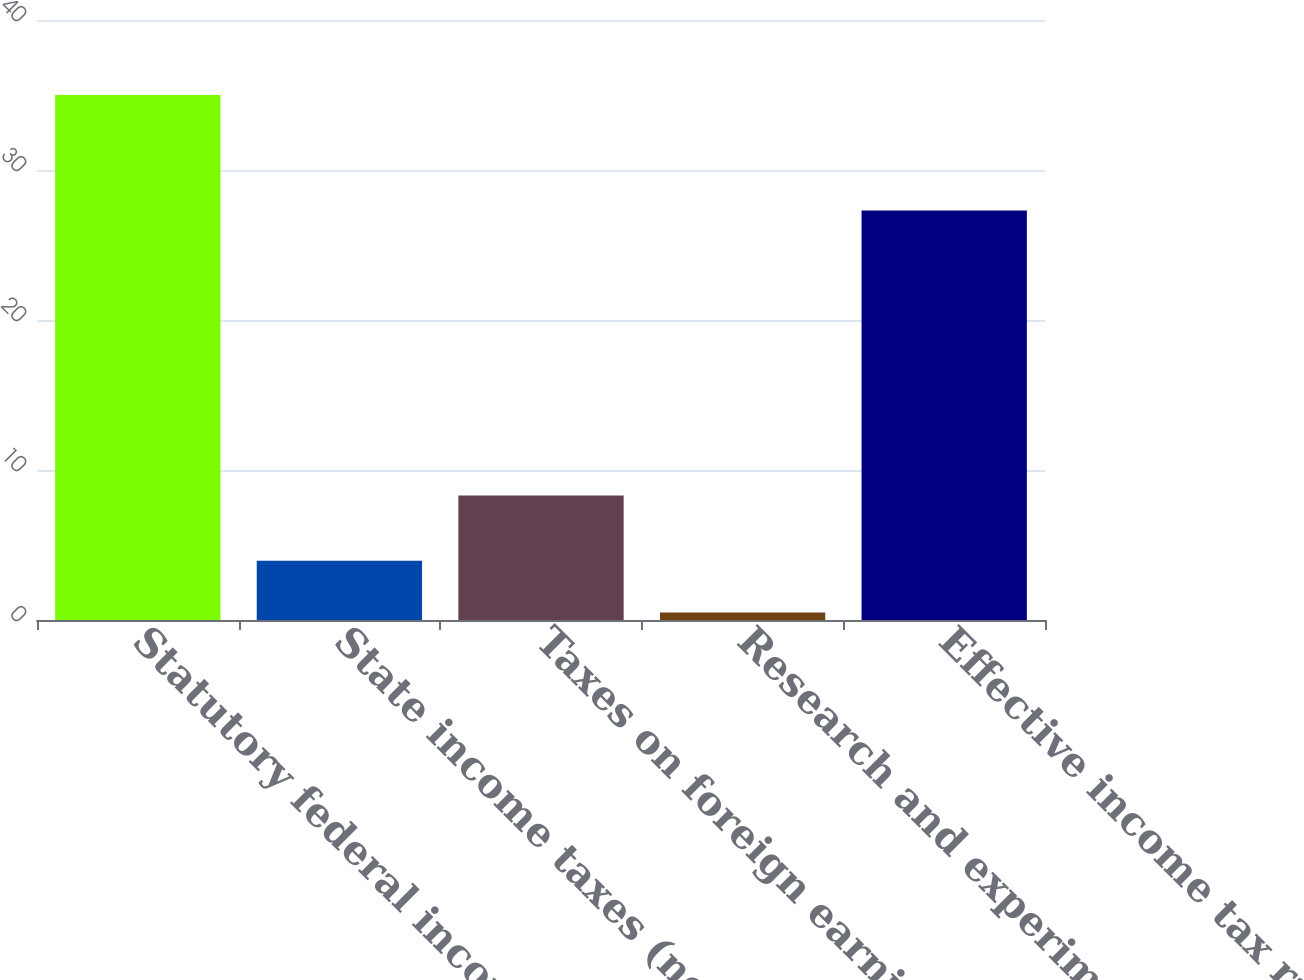<chart> <loc_0><loc_0><loc_500><loc_500><bar_chart><fcel>Statutory federal income tax<fcel>State income taxes (net of<fcel>Taxes on foreign earnings<fcel>Research and experimentation<fcel>Effective income tax rate<nl><fcel>35<fcel>3.95<fcel>8.3<fcel>0.5<fcel>27.3<nl></chart> 